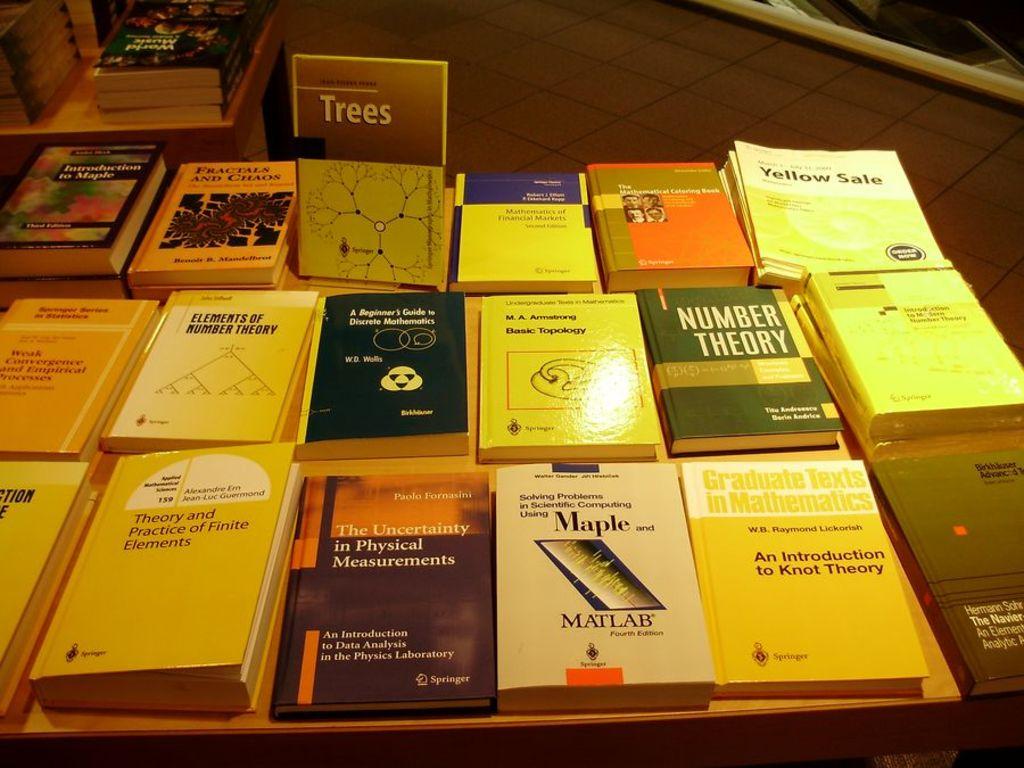Is there a book titled "trees" on the table?
Keep it short and to the point. Yes. 